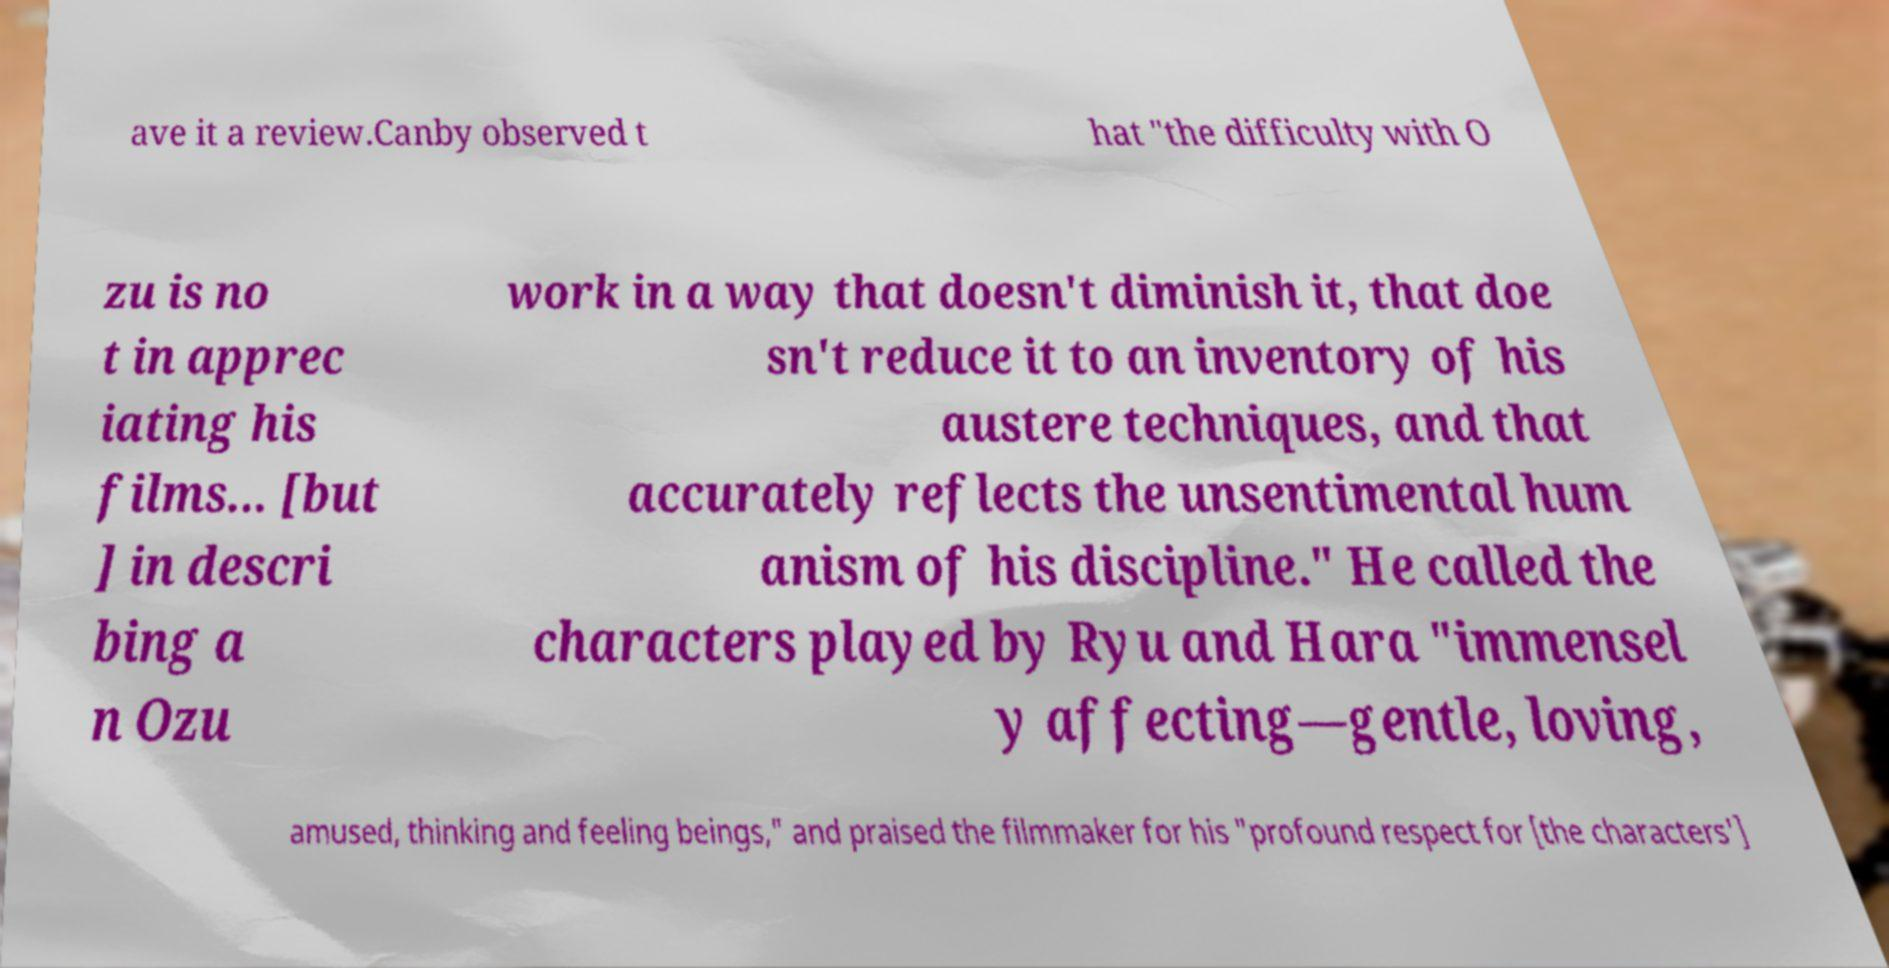Please read and relay the text visible in this image. What does it say? ave it a review.Canby observed t hat "the difficulty with O zu is no t in apprec iating his films... [but ] in descri bing a n Ozu work in a way that doesn't diminish it, that doe sn't reduce it to an inventory of his austere techniques, and that accurately reflects the unsentimental hum anism of his discipline." He called the characters played by Ryu and Hara "immensel y affecting—gentle, loving, amused, thinking and feeling beings," and praised the filmmaker for his "profound respect for [the characters'] 